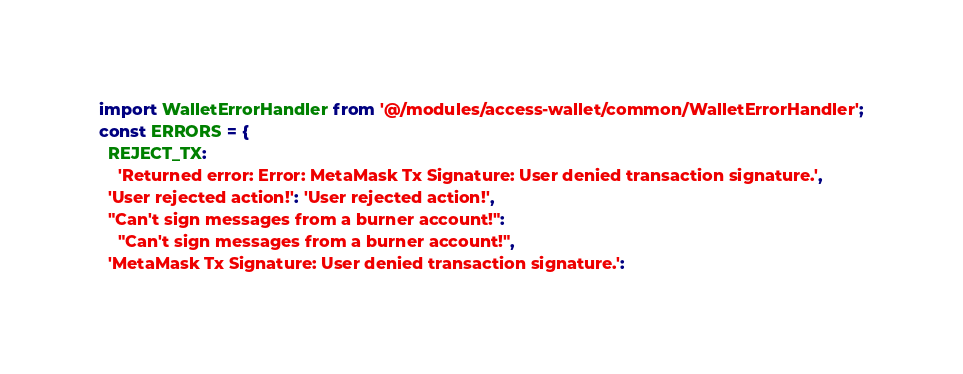<code> <loc_0><loc_0><loc_500><loc_500><_JavaScript_>import WalletErrorHandler from '@/modules/access-wallet/common/WalletErrorHandler';
const ERRORS = {
  REJECT_TX:
    'Returned error: Error: MetaMask Tx Signature: User denied transaction signature.',
  'User rejected action!': 'User rejected action!',
  "Can't sign messages from a burner account!":
    "Can't sign messages from a burner account!",
  'MetaMask Tx Signature: User denied transaction signature.':</code> 